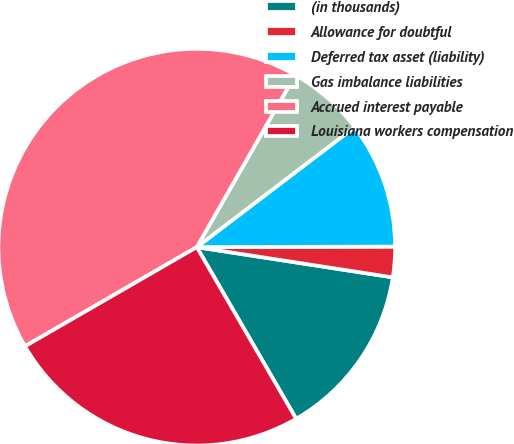<chart> <loc_0><loc_0><loc_500><loc_500><pie_chart><fcel>(in thousands)<fcel>Allowance for doubtful<fcel>Deferred tax asset (liability)<fcel>Gas imbalance liabilities<fcel>Accrued interest payable<fcel>Louisiana workers compensation<nl><fcel>14.21%<fcel>2.48%<fcel>10.3%<fcel>6.39%<fcel>41.59%<fcel>25.02%<nl></chart> 